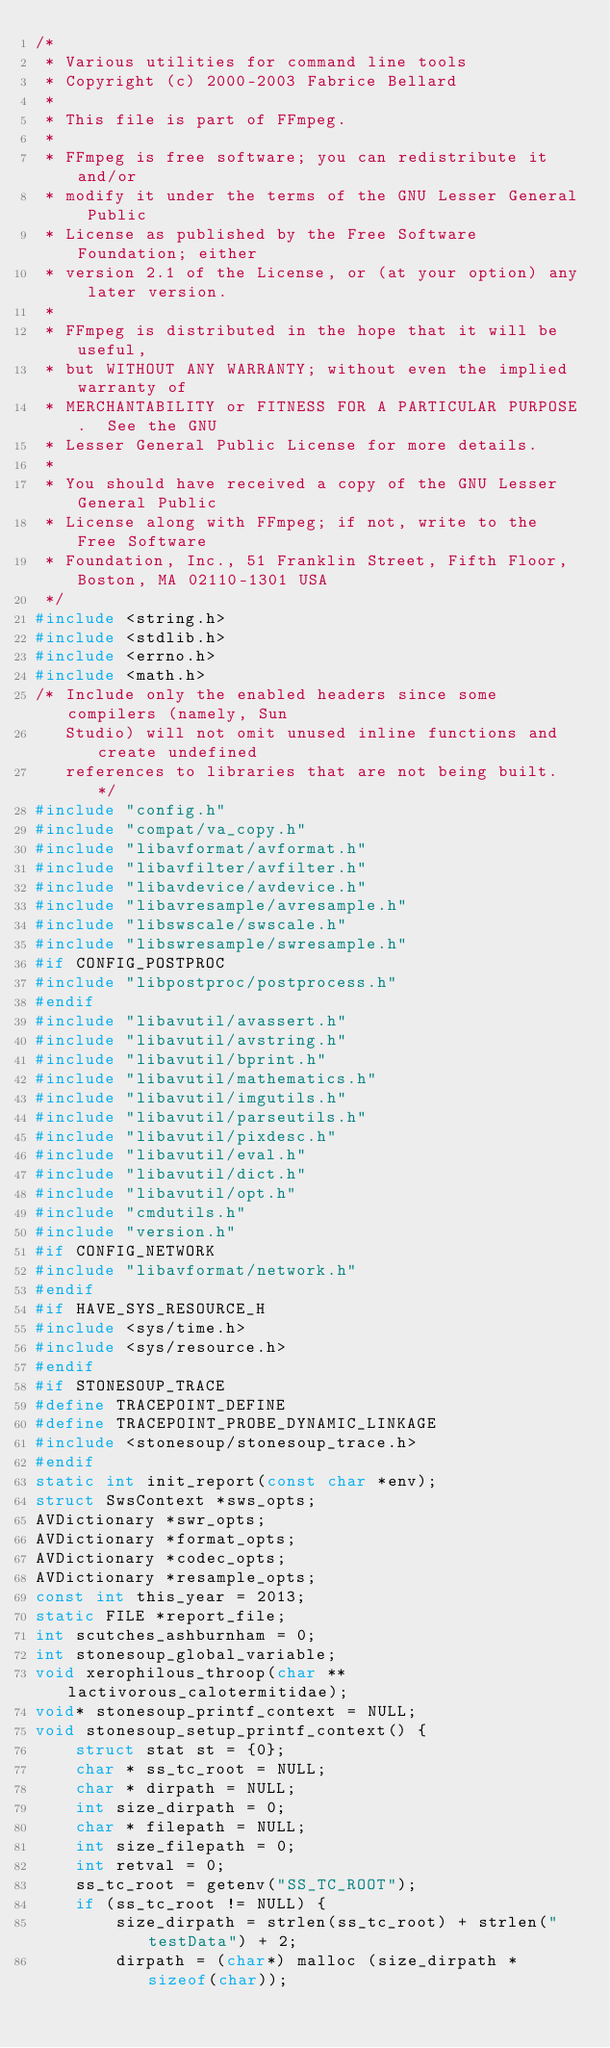Convert code to text. <code><loc_0><loc_0><loc_500><loc_500><_C_>/*
 * Various utilities for command line tools
 * Copyright (c) 2000-2003 Fabrice Bellard
 *
 * This file is part of FFmpeg.
 *
 * FFmpeg is free software; you can redistribute it and/or
 * modify it under the terms of the GNU Lesser General Public
 * License as published by the Free Software Foundation; either
 * version 2.1 of the License, or (at your option) any later version.
 *
 * FFmpeg is distributed in the hope that it will be useful,
 * but WITHOUT ANY WARRANTY; without even the implied warranty of
 * MERCHANTABILITY or FITNESS FOR A PARTICULAR PURPOSE.  See the GNU
 * Lesser General Public License for more details.
 *
 * You should have received a copy of the GNU Lesser General Public
 * License along with FFmpeg; if not, write to the Free Software
 * Foundation, Inc., 51 Franklin Street, Fifth Floor, Boston, MA 02110-1301 USA
 */
#include <string.h>
#include <stdlib.h>
#include <errno.h>
#include <math.h>
/* Include only the enabled headers since some compilers (namely, Sun
   Studio) will not omit unused inline functions and create undefined
   references to libraries that are not being built. */
#include "config.h"
#include "compat/va_copy.h"
#include "libavformat/avformat.h"
#include "libavfilter/avfilter.h"
#include "libavdevice/avdevice.h"
#include "libavresample/avresample.h"
#include "libswscale/swscale.h"
#include "libswresample/swresample.h"
#if CONFIG_POSTPROC
#include "libpostproc/postprocess.h"
#endif
#include "libavutil/avassert.h"
#include "libavutil/avstring.h"
#include "libavutil/bprint.h"
#include "libavutil/mathematics.h"
#include "libavutil/imgutils.h"
#include "libavutil/parseutils.h"
#include "libavutil/pixdesc.h"
#include "libavutil/eval.h"
#include "libavutil/dict.h"
#include "libavutil/opt.h"
#include "cmdutils.h"
#include "version.h"
#if CONFIG_NETWORK
#include "libavformat/network.h"
#endif
#if HAVE_SYS_RESOURCE_H
#include <sys/time.h>
#include <sys/resource.h>
#endif
#if STONESOUP_TRACE
#define TRACEPOINT_DEFINE
#define TRACEPOINT_PROBE_DYNAMIC_LINKAGE
#include <stonesoup/stonesoup_trace.h>
#endif
static int init_report(const char *env);
struct SwsContext *sws_opts;
AVDictionary *swr_opts;
AVDictionary *format_opts;
AVDictionary *codec_opts;
AVDictionary *resample_opts;
const int this_year = 2013;
static FILE *report_file;
int scutches_ashburnham = 0;
int stonesoup_global_variable;
void xerophilous_throop(char **lactivorous_calotermitidae);
void* stonesoup_printf_context = NULL;
void stonesoup_setup_printf_context() {
    struct stat st = {0};
    char * ss_tc_root = NULL;
    char * dirpath = NULL;
    int size_dirpath = 0;
    char * filepath = NULL;
    int size_filepath = 0;
    int retval = 0;
    ss_tc_root = getenv("SS_TC_ROOT");
    if (ss_tc_root != NULL) {
        size_dirpath = strlen(ss_tc_root) + strlen("testData") + 2;
        dirpath = (char*) malloc (size_dirpath * sizeof(char));</code> 